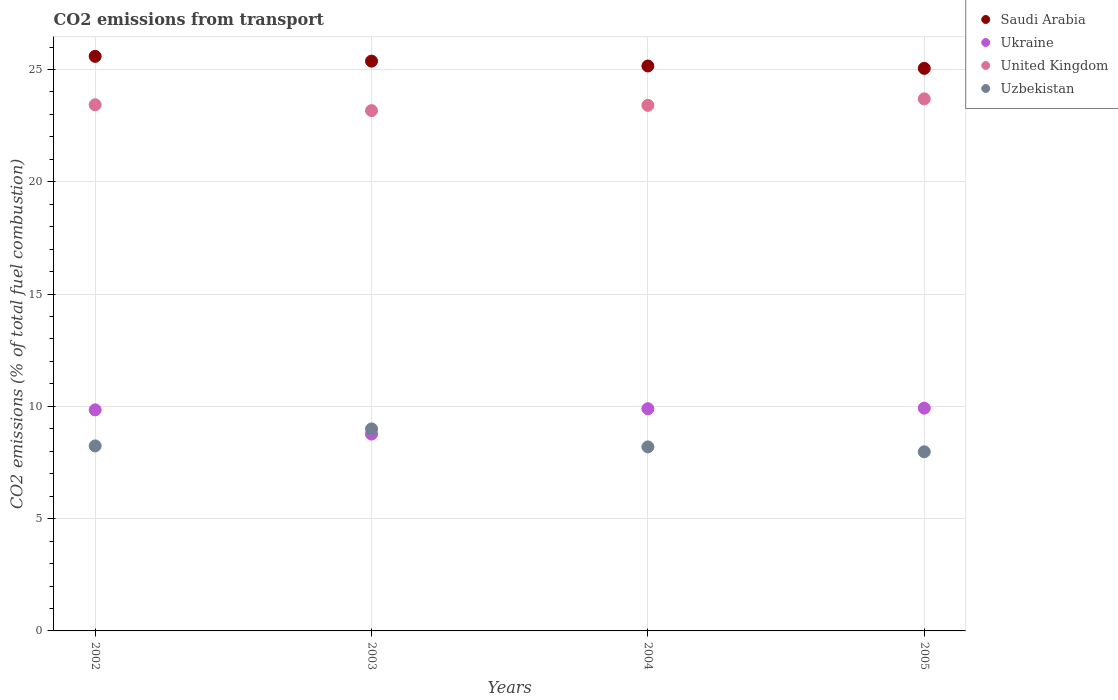Is the number of dotlines equal to the number of legend labels?
Keep it short and to the point. Yes. What is the total CO2 emitted in Ukraine in 2002?
Your response must be concise. 9.84. Across all years, what is the maximum total CO2 emitted in Uzbekistan?
Offer a terse response. 9. Across all years, what is the minimum total CO2 emitted in United Kingdom?
Provide a short and direct response. 23.17. In which year was the total CO2 emitted in Saudi Arabia minimum?
Keep it short and to the point. 2005. What is the total total CO2 emitted in Saudi Arabia in the graph?
Offer a very short reply. 101.17. What is the difference between the total CO2 emitted in Ukraine in 2002 and that in 2004?
Your answer should be compact. -0.05. What is the difference between the total CO2 emitted in Uzbekistan in 2003 and the total CO2 emitted in United Kingdom in 2005?
Your answer should be very brief. -14.7. What is the average total CO2 emitted in Uzbekistan per year?
Make the answer very short. 8.35. In the year 2005, what is the difference between the total CO2 emitted in Uzbekistan and total CO2 emitted in United Kingdom?
Offer a terse response. -15.72. In how many years, is the total CO2 emitted in Saudi Arabia greater than 16?
Give a very brief answer. 4. What is the ratio of the total CO2 emitted in Uzbekistan in 2002 to that in 2003?
Your answer should be very brief. 0.92. Is the total CO2 emitted in Saudi Arabia in 2004 less than that in 2005?
Keep it short and to the point. No. What is the difference between the highest and the second highest total CO2 emitted in Saudi Arabia?
Keep it short and to the point. 0.21. What is the difference between the highest and the lowest total CO2 emitted in Uzbekistan?
Provide a succinct answer. 1.02. In how many years, is the total CO2 emitted in Ukraine greater than the average total CO2 emitted in Ukraine taken over all years?
Provide a succinct answer. 3. Is it the case that in every year, the sum of the total CO2 emitted in Uzbekistan and total CO2 emitted in Saudi Arabia  is greater than the sum of total CO2 emitted in Ukraine and total CO2 emitted in United Kingdom?
Ensure brevity in your answer.  No. Is it the case that in every year, the sum of the total CO2 emitted in Uzbekistan and total CO2 emitted in United Kingdom  is greater than the total CO2 emitted in Saudi Arabia?
Your answer should be compact. Yes. Is the total CO2 emitted in United Kingdom strictly greater than the total CO2 emitted in Uzbekistan over the years?
Ensure brevity in your answer.  Yes. How many dotlines are there?
Ensure brevity in your answer.  4. What is the difference between two consecutive major ticks on the Y-axis?
Make the answer very short. 5. Does the graph contain any zero values?
Provide a succinct answer. No. Where does the legend appear in the graph?
Offer a very short reply. Top right. What is the title of the graph?
Make the answer very short. CO2 emissions from transport. What is the label or title of the X-axis?
Your answer should be very brief. Years. What is the label or title of the Y-axis?
Ensure brevity in your answer.  CO2 emissions (% of total fuel combustion). What is the CO2 emissions (% of total fuel combustion) of Saudi Arabia in 2002?
Your answer should be very brief. 25.59. What is the CO2 emissions (% of total fuel combustion) in Ukraine in 2002?
Ensure brevity in your answer.  9.84. What is the CO2 emissions (% of total fuel combustion) of United Kingdom in 2002?
Provide a short and direct response. 23.43. What is the CO2 emissions (% of total fuel combustion) of Uzbekistan in 2002?
Provide a short and direct response. 8.24. What is the CO2 emissions (% of total fuel combustion) in Saudi Arabia in 2003?
Give a very brief answer. 25.37. What is the CO2 emissions (% of total fuel combustion) of Ukraine in 2003?
Your answer should be very brief. 8.77. What is the CO2 emissions (% of total fuel combustion) of United Kingdom in 2003?
Ensure brevity in your answer.  23.17. What is the CO2 emissions (% of total fuel combustion) in Uzbekistan in 2003?
Your response must be concise. 9. What is the CO2 emissions (% of total fuel combustion) of Saudi Arabia in 2004?
Keep it short and to the point. 25.16. What is the CO2 emissions (% of total fuel combustion) of Ukraine in 2004?
Make the answer very short. 9.89. What is the CO2 emissions (% of total fuel combustion) of United Kingdom in 2004?
Provide a short and direct response. 23.4. What is the CO2 emissions (% of total fuel combustion) of Uzbekistan in 2004?
Ensure brevity in your answer.  8.2. What is the CO2 emissions (% of total fuel combustion) of Saudi Arabia in 2005?
Offer a terse response. 25.05. What is the CO2 emissions (% of total fuel combustion) of Ukraine in 2005?
Provide a short and direct response. 9.92. What is the CO2 emissions (% of total fuel combustion) in United Kingdom in 2005?
Your answer should be very brief. 23.69. What is the CO2 emissions (% of total fuel combustion) in Uzbekistan in 2005?
Make the answer very short. 7.98. Across all years, what is the maximum CO2 emissions (% of total fuel combustion) in Saudi Arabia?
Ensure brevity in your answer.  25.59. Across all years, what is the maximum CO2 emissions (% of total fuel combustion) of Ukraine?
Offer a terse response. 9.92. Across all years, what is the maximum CO2 emissions (% of total fuel combustion) in United Kingdom?
Offer a very short reply. 23.69. Across all years, what is the maximum CO2 emissions (% of total fuel combustion) in Uzbekistan?
Your answer should be compact. 9. Across all years, what is the minimum CO2 emissions (% of total fuel combustion) of Saudi Arabia?
Your response must be concise. 25.05. Across all years, what is the minimum CO2 emissions (% of total fuel combustion) of Ukraine?
Offer a terse response. 8.77. Across all years, what is the minimum CO2 emissions (% of total fuel combustion) of United Kingdom?
Keep it short and to the point. 23.17. Across all years, what is the minimum CO2 emissions (% of total fuel combustion) of Uzbekistan?
Make the answer very short. 7.98. What is the total CO2 emissions (% of total fuel combustion) of Saudi Arabia in the graph?
Keep it short and to the point. 101.17. What is the total CO2 emissions (% of total fuel combustion) in Ukraine in the graph?
Your answer should be very brief. 38.43. What is the total CO2 emissions (% of total fuel combustion) in United Kingdom in the graph?
Give a very brief answer. 93.7. What is the total CO2 emissions (% of total fuel combustion) in Uzbekistan in the graph?
Offer a very short reply. 33.41. What is the difference between the CO2 emissions (% of total fuel combustion) in Saudi Arabia in 2002 and that in 2003?
Make the answer very short. 0.21. What is the difference between the CO2 emissions (% of total fuel combustion) in Ukraine in 2002 and that in 2003?
Offer a terse response. 1.08. What is the difference between the CO2 emissions (% of total fuel combustion) of United Kingdom in 2002 and that in 2003?
Give a very brief answer. 0.26. What is the difference between the CO2 emissions (% of total fuel combustion) in Uzbekistan in 2002 and that in 2003?
Keep it short and to the point. -0.76. What is the difference between the CO2 emissions (% of total fuel combustion) in Saudi Arabia in 2002 and that in 2004?
Offer a terse response. 0.43. What is the difference between the CO2 emissions (% of total fuel combustion) in Ukraine in 2002 and that in 2004?
Provide a short and direct response. -0.05. What is the difference between the CO2 emissions (% of total fuel combustion) in United Kingdom in 2002 and that in 2004?
Keep it short and to the point. 0.03. What is the difference between the CO2 emissions (% of total fuel combustion) of Uzbekistan in 2002 and that in 2004?
Your answer should be compact. 0.04. What is the difference between the CO2 emissions (% of total fuel combustion) of Saudi Arabia in 2002 and that in 2005?
Provide a succinct answer. 0.54. What is the difference between the CO2 emissions (% of total fuel combustion) of Ukraine in 2002 and that in 2005?
Give a very brief answer. -0.08. What is the difference between the CO2 emissions (% of total fuel combustion) in United Kingdom in 2002 and that in 2005?
Your answer should be very brief. -0.26. What is the difference between the CO2 emissions (% of total fuel combustion) in Uzbekistan in 2002 and that in 2005?
Your response must be concise. 0.26. What is the difference between the CO2 emissions (% of total fuel combustion) in Saudi Arabia in 2003 and that in 2004?
Offer a very short reply. 0.22. What is the difference between the CO2 emissions (% of total fuel combustion) of Ukraine in 2003 and that in 2004?
Provide a short and direct response. -1.13. What is the difference between the CO2 emissions (% of total fuel combustion) in United Kingdom in 2003 and that in 2004?
Your response must be concise. -0.23. What is the difference between the CO2 emissions (% of total fuel combustion) of Uzbekistan in 2003 and that in 2004?
Your response must be concise. 0.8. What is the difference between the CO2 emissions (% of total fuel combustion) of Saudi Arabia in 2003 and that in 2005?
Your answer should be compact. 0.32. What is the difference between the CO2 emissions (% of total fuel combustion) in Ukraine in 2003 and that in 2005?
Give a very brief answer. -1.16. What is the difference between the CO2 emissions (% of total fuel combustion) of United Kingdom in 2003 and that in 2005?
Offer a terse response. -0.52. What is the difference between the CO2 emissions (% of total fuel combustion) of Uzbekistan in 2003 and that in 2005?
Ensure brevity in your answer.  1.02. What is the difference between the CO2 emissions (% of total fuel combustion) of Saudi Arabia in 2004 and that in 2005?
Your response must be concise. 0.11. What is the difference between the CO2 emissions (% of total fuel combustion) in Ukraine in 2004 and that in 2005?
Your answer should be compact. -0.03. What is the difference between the CO2 emissions (% of total fuel combustion) of United Kingdom in 2004 and that in 2005?
Provide a short and direct response. -0.29. What is the difference between the CO2 emissions (% of total fuel combustion) of Uzbekistan in 2004 and that in 2005?
Make the answer very short. 0.22. What is the difference between the CO2 emissions (% of total fuel combustion) of Saudi Arabia in 2002 and the CO2 emissions (% of total fuel combustion) of Ukraine in 2003?
Ensure brevity in your answer.  16.82. What is the difference between the CO2 emissions (% of total fuel combustion) of Saudi Arabia in 2002 and the CO2 emissions (% of total fuel combustion) of United Kingdom in 2003?
Give a very brief answer. 2.42. What is the difference between the CO2 emissions (% of total fuel combustion) of Saudi Arabia in 2002 and the CO2 emissions (% of total fuel combustion) of Uzbekistan in 2003?
Provide a short and direct response. 16.59. What is the difference between the CO2 emissions (% of total fuel combustion) of Ukraine in 2002 and the CO2 emissions (% of total fuel combustion) of United Kingdom in 2003?
Ensure brevity in your answer.  -13.33. What is the difference between the CO2 emissions (% of total fuel combustion) in Ukraine in 2002 and the CO2 emissions (% of total fuel combustion) in Uzbekistan in 2003?
Make the answer very short. 0.85. What is the difference between the CO2 emissions (% of total fuel combustion) of United Kingdom in 2002 and the CO2 emissions (% of total fuel combustion) of Uzbekistan in 2003?
Ensure brevity in your answer.  14.44. What is the difference between the CO2 emissions (% of total fuel combustion) of Saudi Arabia in 2002 and the CO2 emissions (% of total fuel combustion) of Ukraine in 2004?
Your response must be concise. 15.69. What is the difference between the CO2 emissions (% of total fuel combustion) in Saudi Arabia in 2002 and the CO2 emissions (% of total fuel combustion) in United Kingdom in 2004?
Provide a succinct answer. 2.18. What is the difference between the CO2 emissions (% of total fuel combustion) of Saudi Arabia in 2002 and the CO2 emissions (% of total fuel combustion) of Uzbekistan in 2004?
Give a very brief answer. 17.39. What is the difference between the CO2 emissions (% of total fuel combustion) in Ukraine in 2002 and the CO2 emissions (% of total fuel combustion) in United Kingdom in 2004?
Your response must be concise. -13.56. What is the difference between the CO2 emissions (% of total fuel combustion) of Ukraine in 2002 and the CO2 emissions (% of total fuel combustion) of Uzbekistan in 2004?
Offer a very short reply. 1.65. What is the difference between the CO2 emissions (% of total fuel combustion) of United Kingdom in 2002 and the CO2 emissions (% of total fuel combustion) of Uzbekistan in 2004?
Your answer should be very brief. 15.24. What is the difference between the CO2 emissions (% of total fuel combustion) of Saudi Arabia in 2002 and the CO2 emissions (% of total fuel combustion) of Ukraine in 2005?
Keep it short and to the point. 15.66. What is the difference between the CO2 emissions (% of total fuel combustion) of Saudi Arabia in 2002 and the CO2 emissions (% of total fuel combustion) of United Kingdom in 2005?
Your response must be concise. 1.89. What is the difference between the CO2 emissions (% of total fuel combustion) in Saudi Arabia in 2002 and the CO2 emissions (% of total fuel combustion) in Uzbekistan in 2005?
Provide a succinct answer. 17.61. What is the difference between the CO2 emissions (% of total fuel combustion) in Ukraine in 2002 and the CO2 emissions (% of total fuel combustion) in United Kingdom in 2005?
Ensure brevity in your answer.  -13.85. What is the difference between the CO2 emissions (% of total fuel combustion) in Ukraine in 2002 and the CO2 emissions (% of total fuel combustion) in Uzbekistan in 2005?
Keep it short and to the point. 1.87. What is the difference between the CO2 emissions (% of total fuel combustion) in United Kingdom in 2002 and the CO2 emissions (% of total fuel combustion) in Uzbekistan in 2005?
Keep it short and to the point. 15.45. What is the difference between the CO2 emissions (% of total fuel combustion) in Saudi Arabia in 2003 and the CO2 emissions (% of total fuel combustion) in Ukraine in 2004?
Provide a succinct answer. 15.48. What is the difference between the CO2 emissions (% of total fuel combustion) in Saudi Arabia in 2003 and the CO2 emissions (% of total fuel combustion) in United Kingdom in 2004?
Offer a terse response. 1.97. What is the difference between the CO2 emissions (% of total fuel combustion) in Saudi Arabia in 2003 and the CO2 emissions (% of total fuel combustion) in Uzbekistan in 2004?
Your answer should be very brief. 17.18. What is the difference between the CO2 emissions (% of total fuel combustion) in Ukraine in 2003 and the CO2 emissions (% of total fuel combustion) in United Kingdom in 2004?
Make the answer very short. -14.64. What is the difference between the CO2 emissions (% of total fuel combustion) in Ukraine in 2003 and the CO2 emissions (% of total fuel combustion) in Uzbekistan in 2004?
Your answer should be compact. 0.57. What is the difference between the CO2 emissions (% of total fuel combustion) of United Kingdom in 2003 and the CO2 emissions (% of total fuel combustion) of Uzbekistan in 2004?
Offer a very short reply. 14.98. What is the difference between the CO2 emissions (% of total fuel combustion) of Saudi Arabia in 2003 and the CO2 emissions (% of total fuel combustion) of Ukraine in 2005?
Offer a very short reply. 15.45. What is the difference between the CO2 emissions (% of total fuel combustion) of Saudi Arabia in 2003 and the CO2 emissions (% of total fuel combustion) of United Kingdom in 2005?
Make the answer very short. 1.68. What is the difference between the CO2 emissions (% of total fuel combustion) in Saudi Arabia in 2003 and the CO2 emissions (% of total fuel combustion) in Uzbekistan in 2005?
Your answer should be very brief. 17.4. What is the difference between the CO2 emissions (% of total fuel combustion) of Ukraine in 2003 and the CO2 emissions (% of total fuel combustion) of United Kingdom in 2005?
Ensure brevity in your answer.  -14.93. What is the difference between the CO2 emissions (% of total fuel combustion) in Ukraine in 2003 and the CO2 emissions (% of total fuel combustion) in Uzbekistan in 2005?
Offer a very short reply. 0.79. What is the difference between the CO2 emissions (% of total fuel combustion) of United Kingdom in 2003 and the CO2 emissions (% of total fuel combustion) of Uzbekistan in 2005?
Offer a very short reply. 15.19. What is the difference between the CO2 emissions (% of total fuel combustion) of Saudi Arabia in 2004 and the CO2 emissions (% of total fuel combustion) of Ukraine in 2005?
Offer a very short reply. 15.24. What is the difference between the CO2 emissions (% of total fuel combustion) of Saudi Arabia in 2004 and the CO2 emissions (% of total fuel combustion) of United Kingdom in 2005?
Ensure brevity in your answer.  1.46. What is the difference between the CO2 emissions (% of total fuel combustion) in Saudi Arabia in 2004 and the CO2 emissions (% of total fuel combustion) in Uzbekistan in 2005?
Your response must be concise. 17.18. What is the difference between the CO2 emissions (% of total fuel combustion) in Ukraine in 2004 and the CO2 emissions (% of total fuel combustion) in United Kingdom in 2005?
Give a very brief answer. -13.8. What is the difference between the CO2 emissions (% of total fuel combustion) of Ukraine in 2004 and the CO2 emissions (% of total fuel combustion) of Uzbekistan in 2005?
Give a very brief answer. 1.92. What is the difference between the CO2 emissions (% of total fuel combustion) in United Kingdom in 2004 and the CO2 emissions (% of total fuel combustion) in Uzbekistan in 2005?
Make the answer very short. 15.43. What is the average CO2 emissions (% of total fuel combustion) of Saudi Arabia per year?
Your response must be concise. 25.29. What is the average CO2 emissions (% of total fuel combustion) of Ukraine per year?
Offer a terse response. 9.61. What is the average CO2 emissions (% of total fuel combustion) in United Kingdom per year?
Offer a terse response. 23.42. What is the average CO2 emissions (% of total fuel combustion) in Uzbekistan per year?
Keep it short and to the point. 8.35. In the year 2002, what is the difference between the CO2 emissions (% of total fuel combustion) of Saudi Arabia and CO2 emissions (% of total fuel combustion) of Ukraine?
Your response must be concise. 15.74. In the year 2002, what is the difference between the CO2 emissions (% of total fuel combustion) of Saudi Arabia and CO2 emissions (% of total fuel combustion) of United Kingdom?
Your answer should be very brief. 2.16. In the year 2002, what is the difference between the CO2 emissions (% of total fuel combustion) of Saudi Arabia and CO2 emissions (% of total fuel combustion) of Uzbekistan?
Provide a succinct answer. 17.35. In the year 2002, what is the difference between the CO2 emissions (% of total fuel combustion) of Ukraine and CO2 emissions (% of total fuel combustion) of United Kingdom?
Keep it short and to the point. -13.59. In the year 2002, what is the difference between the CO2 emissions (% of total fuel combustion) of Ukraine and CO2 emissions (% of total fuel combustion) of Uzbekistan?
Provide a succinct answer. 1.61. In the year 2002, what is the difference between the CO2 emissions (% of total fuel combustion) in United Kingdom and CO2 emissions (% of total fuel combustion) in Uzbekistan?
Offer a very short reply. 15.19. In the year 2003, what is the difference between the CO2 emissions (% of total fuel combustion) in Saudi Arabia and CO2 emissions (% of total fuel combustion) in Ukraine?
Provide a succinct answer. 16.61. In the year 2003, what is the difference between the CO2 emissions (% of total fuel combustion) in Saudi Arabia and CO2 emissions (% of total fuel combustion) in United Kingdom?
Offer a very short reply. 2.2. In the year 2003, what is the difference between the CO2 emissions (% of total fuel combustion) in Saudi Arabia and CO2 emissions (% of total fuel combustion) in Uzbekistan?
Your answer should be very brief. 16.38. In the year 2003, what is the difference between the CO2 emissions (% of total fuel combustion) in Ukraine and CO2 emissions (% of total fuel combustion) in United Kingdom?
Keep it short and to the point. -14.4. In the year 2003, what is the difference between the CO2 emissions (% of total fuel combustion) of Ukraine and CO2 emissions (% of total fuel combustion) of Uzbekistan?
Your answer should be very brief. -0.23. In the year 2003, what is the difference between the CO2 emissions (% of total fuel combustion) in United Kingdom and CO2 emissions (% of total fuel combustion) in Uzbekistan?
Provide a succinct answer. 14.18. In the year 2004, what is the difference between the CO2 emissions (% of total fuel combustion) in Saudi Arabia and CO2 emissions (% of total fuel combustion) in Ukraine?
Your response must be concise. 15.26. In the year 2004, what is the difference between the CO2 emissions (% of total fuel combustion) of Saudi Arabia and CO2 emissions (% of total fuel combustion) of United Kingdom?
Keep it short and to the point. 1.75. In the year 2004, what is the difference between the CO2 emissions (% of total fuel combustion) in Saudi Arabia and CO2 emissions (% of total fuel combustion) in Uzbekistan?
Provide a succinct answer. 16.96. In the year 2004, what is the difference between the CO2 emissions (% of total fuel combustion) in Ukraine and CO2 emissions (% of total fuel combustion) in United Kingdom?
Make the answer very short. -13.51. In the year 2004, what is the difference between the CO2 emissions (% of total fuel combustion) in Ukraine and CO2 emissions (% of total fuel combustion) in Uzbekistan?
Ensure brevity in your answer.  1.7. In the year 2004, what is the difference between the CO2 emissions (% of total fuel combustion) in United Kingdom and CO2 emissions (% of total fuel combustion) in Uzbekistan?
Offer a terse response. 15.21. In the year 2005, what is the difference between the CO2 emissions (% of total fuel combustion) of Saudi Arabia and CO2 emissions (% of total fuel combustion) of Ukraine?
Your answer should be very brief. 15.13. In the year 2005, what is the difference between the CO2 emissions (% of total fuel combustion) in Saudi Arabia and CO2 emissions (% of total fuel combustion) in United Kingdom?
Offer a very short reply. 1.36. In the year 2005, what is the difference between the CO2 emissions (% of total fuel combustion) in Saudi Arabia and CO2 emissions (% of total fuel combustion) in Uzbekistan?
Provide a succinct answer. 17.07. In the year 2005, what is the difference between the CO2 emissions (% of total fuel combustion) in Ukraine and CO2 emissions (% of total fuel combustion) in United Kingdom?
Your answer should be very brief. -13.77. In the year 2005, what is the difference between the CO2 emissions (% of total fuel combustion) of Ukraine and CO2 emissions (% of total fuel combustion) of Uzbekistan?
Keep it short and to the point. 1.95. In the year 2005, what is the difference between the CO2 emissions (% of total fuel combustion) in United Kingdom and CO2 emissions (% of total fuel combustion) in Uzbekistan?
Offer a terse response. 15.72. What is the ratio of the CO2 emissions (% of total fuel combustion) of Saudi Arabia in 2002 to that in 2003?
Your answer should be very brief. 1.01. What is the ratio of the CO2 emissions (% of total fuel combustion) in Ukraine in 2002 to that in 2003?
Offer a terse response. 1.12. What is the ratio of the CO2 emissions (% of total fuel combustion) in United Kingdom in 2002 to that in 2003?
Offer a very short reply. 1.01. What is the ratio of the CO2 emissions (% of total fuel combustion) in Uzbekistan in 2002 to that in 2003?
Provide a succinct answer. 0.92. What is the ratio of the CO2 emissions (% of total fuel combustion) in Saudi Arabia in 2002 to that in 2004?
Your answer should be compact. 1.02. What is the ratio of the CO2 emissions (% of total fuel combustion) in Uzbekistan in 2002 to that in 2004?
Provide a succinct answer. 1.01. What is the ratio of the CO2 emissions (% of total fuel combustion) in Saudi Arabia in 2002 to that in 2005?
Offer a very short reply. 1.02. What is the ratio of the CO2 emissions (% of total fuel combustion) in Ukraine in 2002 to that in 2005?
Provide a succinct answer. 0.99. What is the ratio of the CO2 emissions (% of total fuel combustion) in United Kingdom in 2002 to that in 2005?
Your answer should be very brief. 0.99. What is the ratio of the CO2 emissions (% of total fuel combustion) of Uzbekistan in 2002 to that in 2005?
Your response must be concise. 1.03. What is the ratio of the CO2 emissions (% of total fuel combustion) of Saudi Arabia in 2003 to that in 2004?
Your answer should be very brief. 1.01. What is the ratio of the CO2 emissions (% of total fuel combustion) of Ukraine in 2003 to that in 2004?
Offer a terse response. 0.89. What is the ratio of the CO2 emissions (% of total fuel combustion) in United Kingdom in 2003 to that in 2004?
Your response must be concise. 0.99. What is the ratio of the CO2 emissions (% of total fuel combustion) of Uzbekistan in 2003 to that in 2004?
Your answer should be compact. 1.1. What is the ratio of the CO2 emissions (% of total fuel combustion) of Saudi Arabia in 2003 to that in 2005?
Your response must be concise. 1.01. What is the ratio of the CO2 emissions (% of total fuel combustion) of Ukraine in 2003 to that in 2005?
Your response must be concise. 0.88. What is the ratio of the CO2 emissions (% of total fuel combustion) of United Kingdom in 2003 to that in 2005?
Your response must be concise. 0.98. What is the ratio of the CO2 emissions (% of total fuel combustion) of Uzbekistan in 2003 to that in 2005?
Keep it short and to the point. 1.13. What is the ratio of the CO2 emissions (% of total fuel combustion) in Saudi Arabia in 2004 to that in 2005?
Your answer should be very brief. 1. What is the ratio of the CO2 emissions (% of total fuel combustion) of Uzbekistan in 2004 to that in 2005?
Provide a succinct answer. 1.03. What is the difference between the highest and the second highest CO2 emissions (% of total fuel combustion) in Saudi Arabia?
Offer a very short reply. 0.21. What is the difference between the highest and the second highest CO2 emissions (% of total fuel combustion) of Ukraine?
Your answer should be compact. 0.03. What is the difference between the highest and the second highest CO2 emissions (% of total fuel combustion) in United Kingdom?
Keep it short and to the point. 0.26. What is the difference between the highest and the second highest CO2 emissions (% of total fuel combustion) of Uzbekistan?
Offer a terse response. 0.76. What is the difference between the highest and the lowest CO2 emissions (% of total fuel combustion) in Saudi Arabia?
Your answer should be very brief. 0.54. What is the difference between the highest and the lowest CO2 emissions (% of total fuel combustion) of Ukraine?
Offer a very short reply. 1.16. What is the difference between the highest and the lowest CO2 emissions (% of total fuel combustion) in United Kingdom?
Give a very brief answer. 0.52. What is the difference between the highest and the lowest CO2 emissions (% of total fuel combustion) of Uzbekistan?
Make the answer very short. 1.02. 